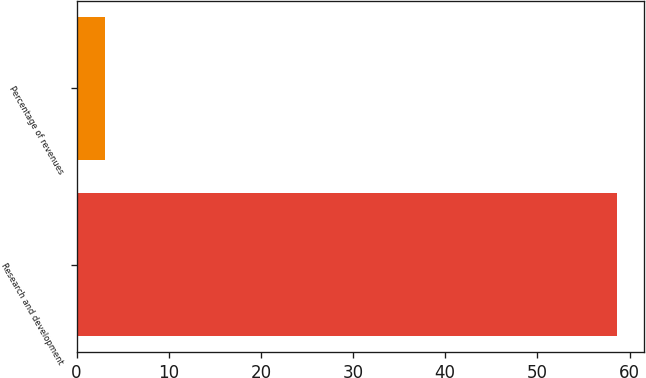<chart> <loc_0><loc_0><loc_500><loc_500><bar_chart><fcel>Research and development<fcel>Percentage of revenues<nl><fcel>58.6<fcel>3.1<nl></chart> 